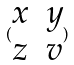<formula> <loc_0><loc_0><loc_500><loc_500>( \begin{matrix} x & y \\ z & v \end{matrix} )</formula> 